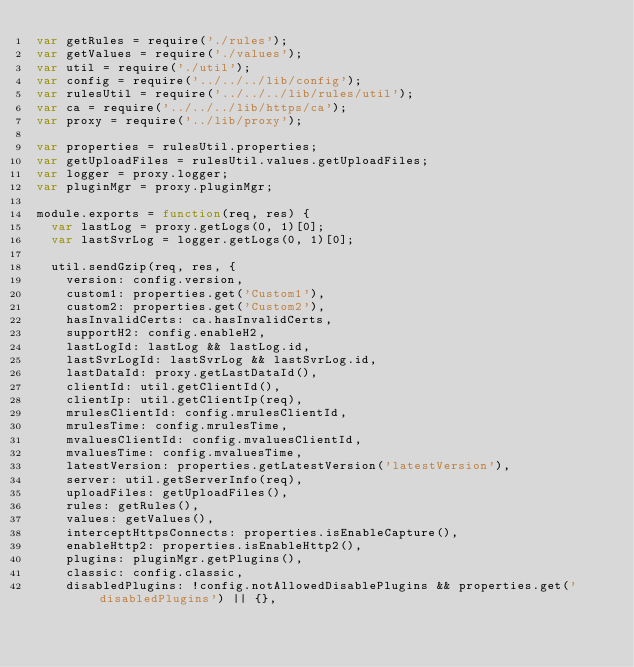Convert code to text. <code><loc_0><loc_0><loc_500><loc_500><_JavaScript_>var getRules = require('./rules');
var getValues = require('./values');
var util = require('./util');
var config = require('../../../lib/config');
var rulesUtil = require('../../../lib/rules/util');
var ca = require('../../../lib/https/ca');
var proxy = require('../lib/proxy');

var properties = rulesUtil.properties;
var getUploadFiles = rulesUtil.values.getUploadFiles;
var logger = proxy.logger;
var pluginMgr = proxy.pluginMgr;

module.exports = function(req, res) {
  var lastLog = proxy.getLogs(0, 1)[0];
  var lastSvrLog = logger.getLogs(0, 1)[0];

  util.sendGzip(req, res, {
    version: config.version,
    custom1: properties.get('Custom1'),
    custom2: properties.get('Custom2'),
    hasInvalidCerts: ca.hasInvalidCerts,
    supportH2: config.enableH2,
    lastLogId: lastLog && lastLog.id,
    lastSvrLogId: lastSvrLog && lastSvrLog.id,
    lastDataId: proxy.getLastDataId(),
    clientId: util.getClientId(),
    clientIp: util.getClientIp(req),
    mrulesClientId: config.mrulesClientId,
    mrulesTime: config.mrulesTime,
    mvaluesClientId: config.mvaluesClientId,
    mvaluesTime: config.mvaluesTime,
    latestVersion: properties.getLatestVersion('latestVersion'),
    server: util.getServerInfo(req),
    uploadFiles: getUploadFiles(),
    rules: getRules(),
    values: getValues(),
    interceptHttpsConnects: properties.isEnableCapture(),
    enableHttp2: properties.isEnableHttp2(),
    plugins: pluginMgr.getPlugins(),
    classic: config.classic,
    disabledPlugins: !config.notAllowedDisablePlugins && properties.get('disabledPlugins') || {},</code> 